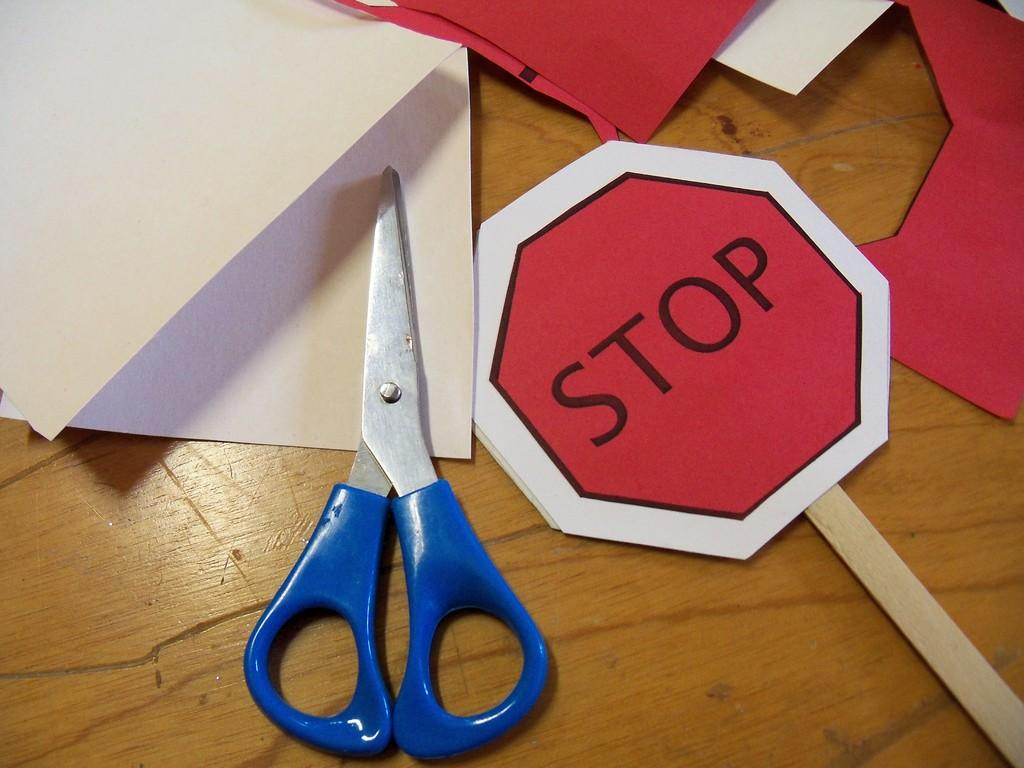Provide a one-sentence caption for the provided image. There's a paper stop sign besides a scissor. 